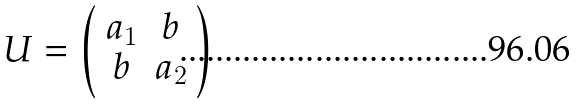<formula> <loc_0><loc_0><loc_500><loc_500>U = \left ( \begin{array} { c c } a _ { 1 } & b \\ b & a _ { 2 } \end{array} \right )</formula> 